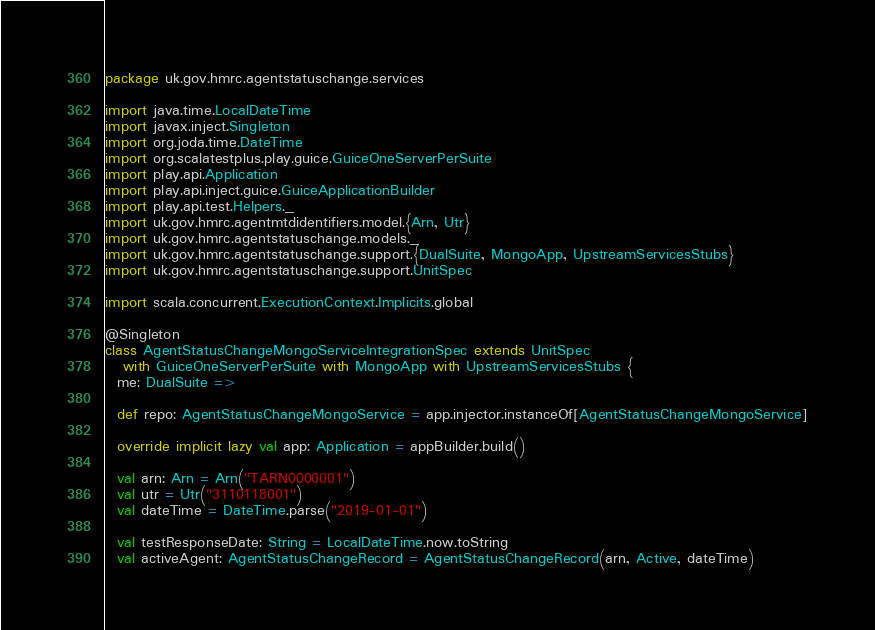<code> <loc_0><loc_0><loc_500><loc_500><_Scala_>package uk.gov.hmrc.agentstatuschange.services

import java.time.LocalDateTime
import javax.inject.Singleton
import org.joda.time.DateTime
import org.scalatestplus.play.guice.GuiceOneServerPerSuite
import play.api.Application
import play.api.inject.guice.GuiceApplicationBuilder
import play.api.test.Helpers._
import uk.gov.hmrc.agentmtdidentifiers.model.{Arn, Utr}
import uk.gov.hmrc.agentstatuschange.models._
import uk.gov.hmrc.agentstatuschange.support.{DualSuite, MongoApp, UpstreamServicesStubs}
import uk.gov.hmrc.agentstatuschange.support.UnitSpec

import scala.concurrent.ExecutionContext.Implicits.global

@Singleton
class AgentStatusChangeMongoServiceIntegrationSpec extends UnitSpec
   with GuiceOneServerPerSuite with MongoApp with UpstreamServicesStubs {
  me: DualSuite =>

  def repo: AgentStatusChangeMongoService = app.injector.instanceOf[AgentStatusChangeMongoService]

  override implicit lazy val app: Application = appBuilder.build()

  val arn: Arn = Arn("TARN0000001")
  val utr = Utr("3110118001")
  val dateTime = DateTime.parse("2019-01-01")

  val testResponseDate: String = LocalDateTime.now.toString
  val activeAgent: AgentStatusChangeRecord = AgentStatusChangeRecord(arn, Active, dateTime)</code> 